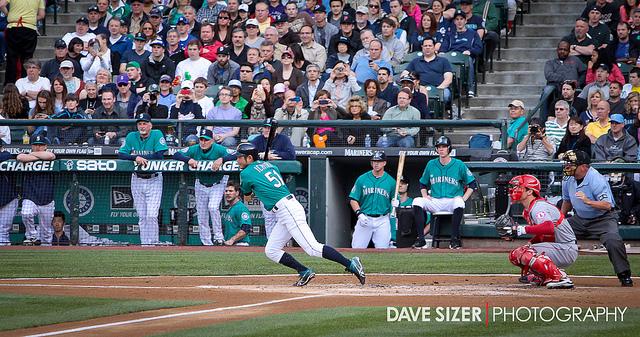Is he serving the ball?
Write a very short answer. No. What color are the uniforms?
Give a very brief answer. Teal and white. Can you name the team wearing teal blue?
Short answer required. No. What kind of game is being played?
Answer briefly. Baseball. 